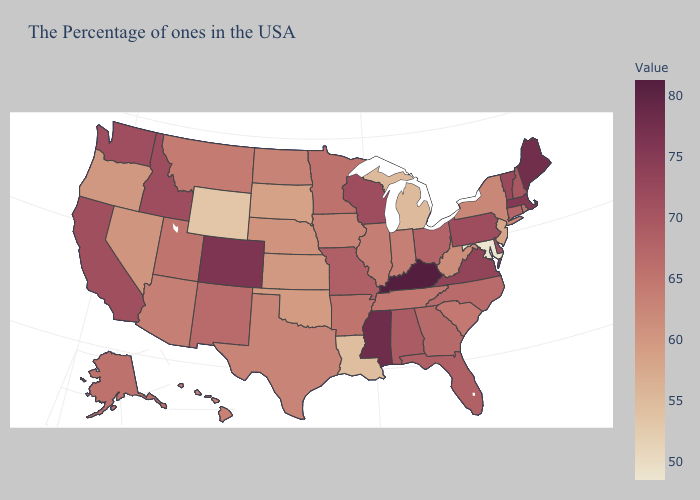Does Connecticut have a higher value than Wisconsin?
Concise answer only. No. Which states have the lowest value in the USA?
Write a very short answer. Maryland. 